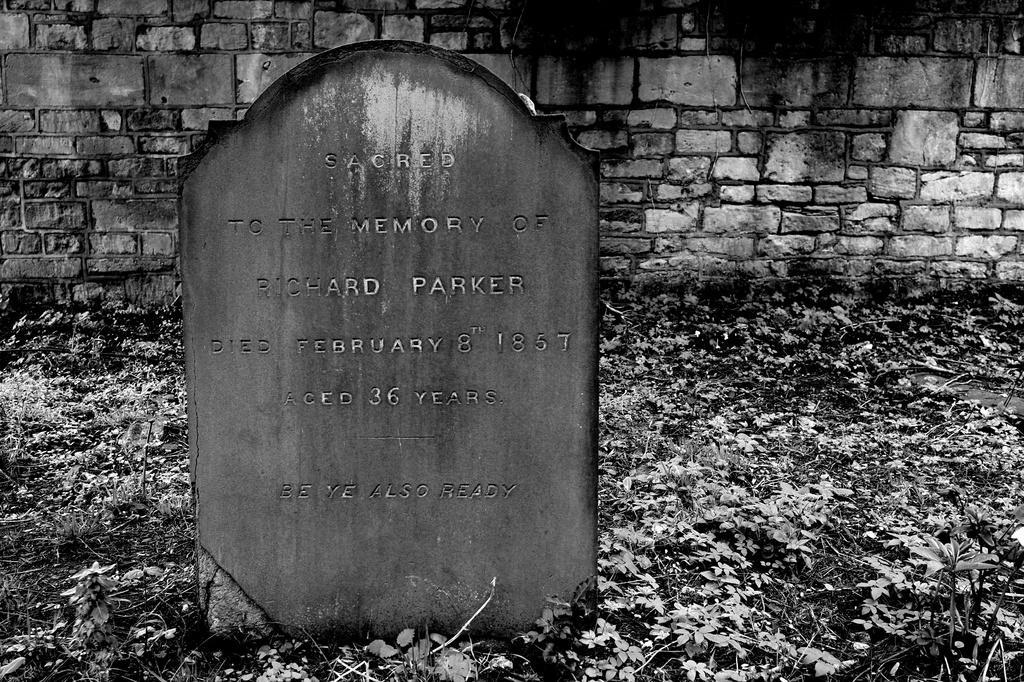In one or two sentences, can you explain what this image depicts? This is a black and white image and here we can see a lay stone with some text. In the background, there is a wall. At the bottom, there are leaves on the ground. 